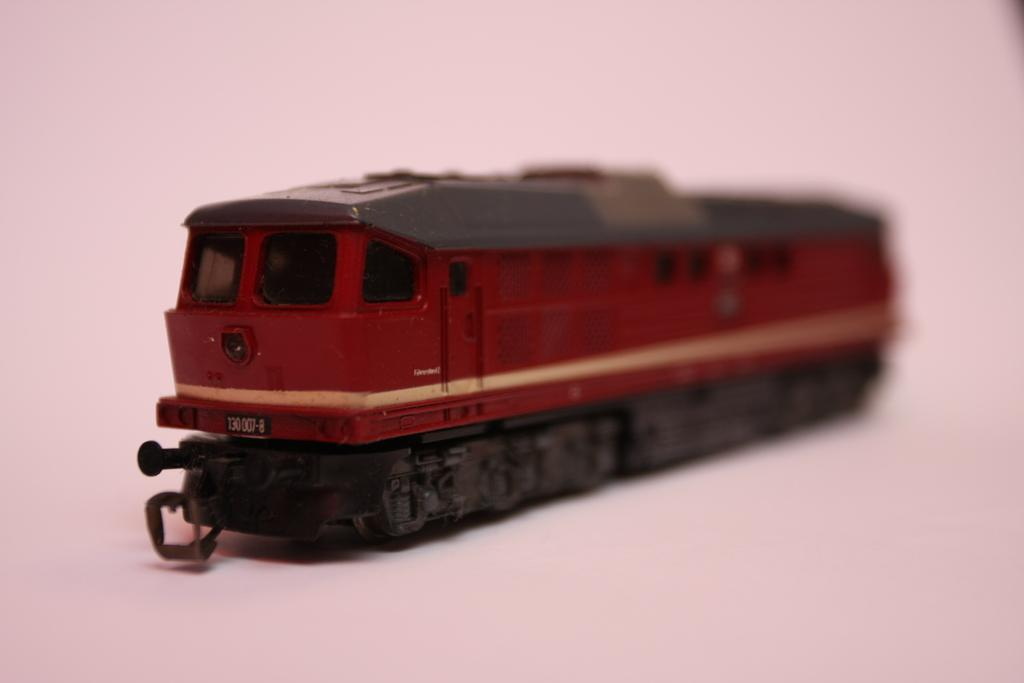What is the main subject of the image? The main subject of the image is a toy train. Can you describe the location of the toy train in the image? The toy train is on a surface in the image. What type of activity is the flock of birds participating in near the toy train? There are no birds present in the image, so it is not possible to answer that question. 